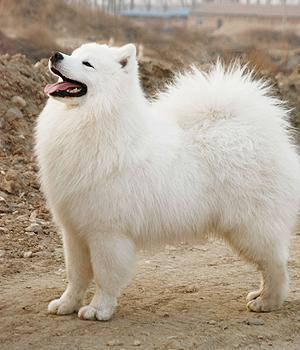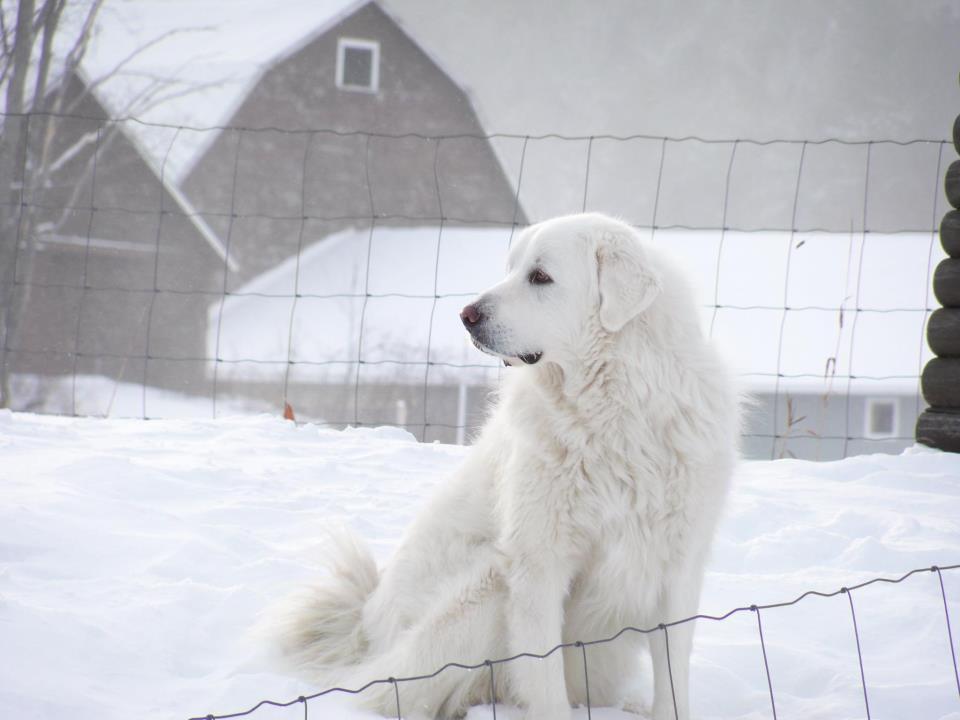The first image is the image on the left, the second image is the image on the right. Assess this claim about the two images: "There is a dog standing in snow in the images.". Correct or not? Answer yes or no. Yes. 